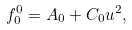<formula> <loc_0><loc_0><loc_500><loc_500>f _ { 0 } ^ { 0 } = A _ { 0 } + C _ { 0 } u ^ { 2 } ,</formula> 